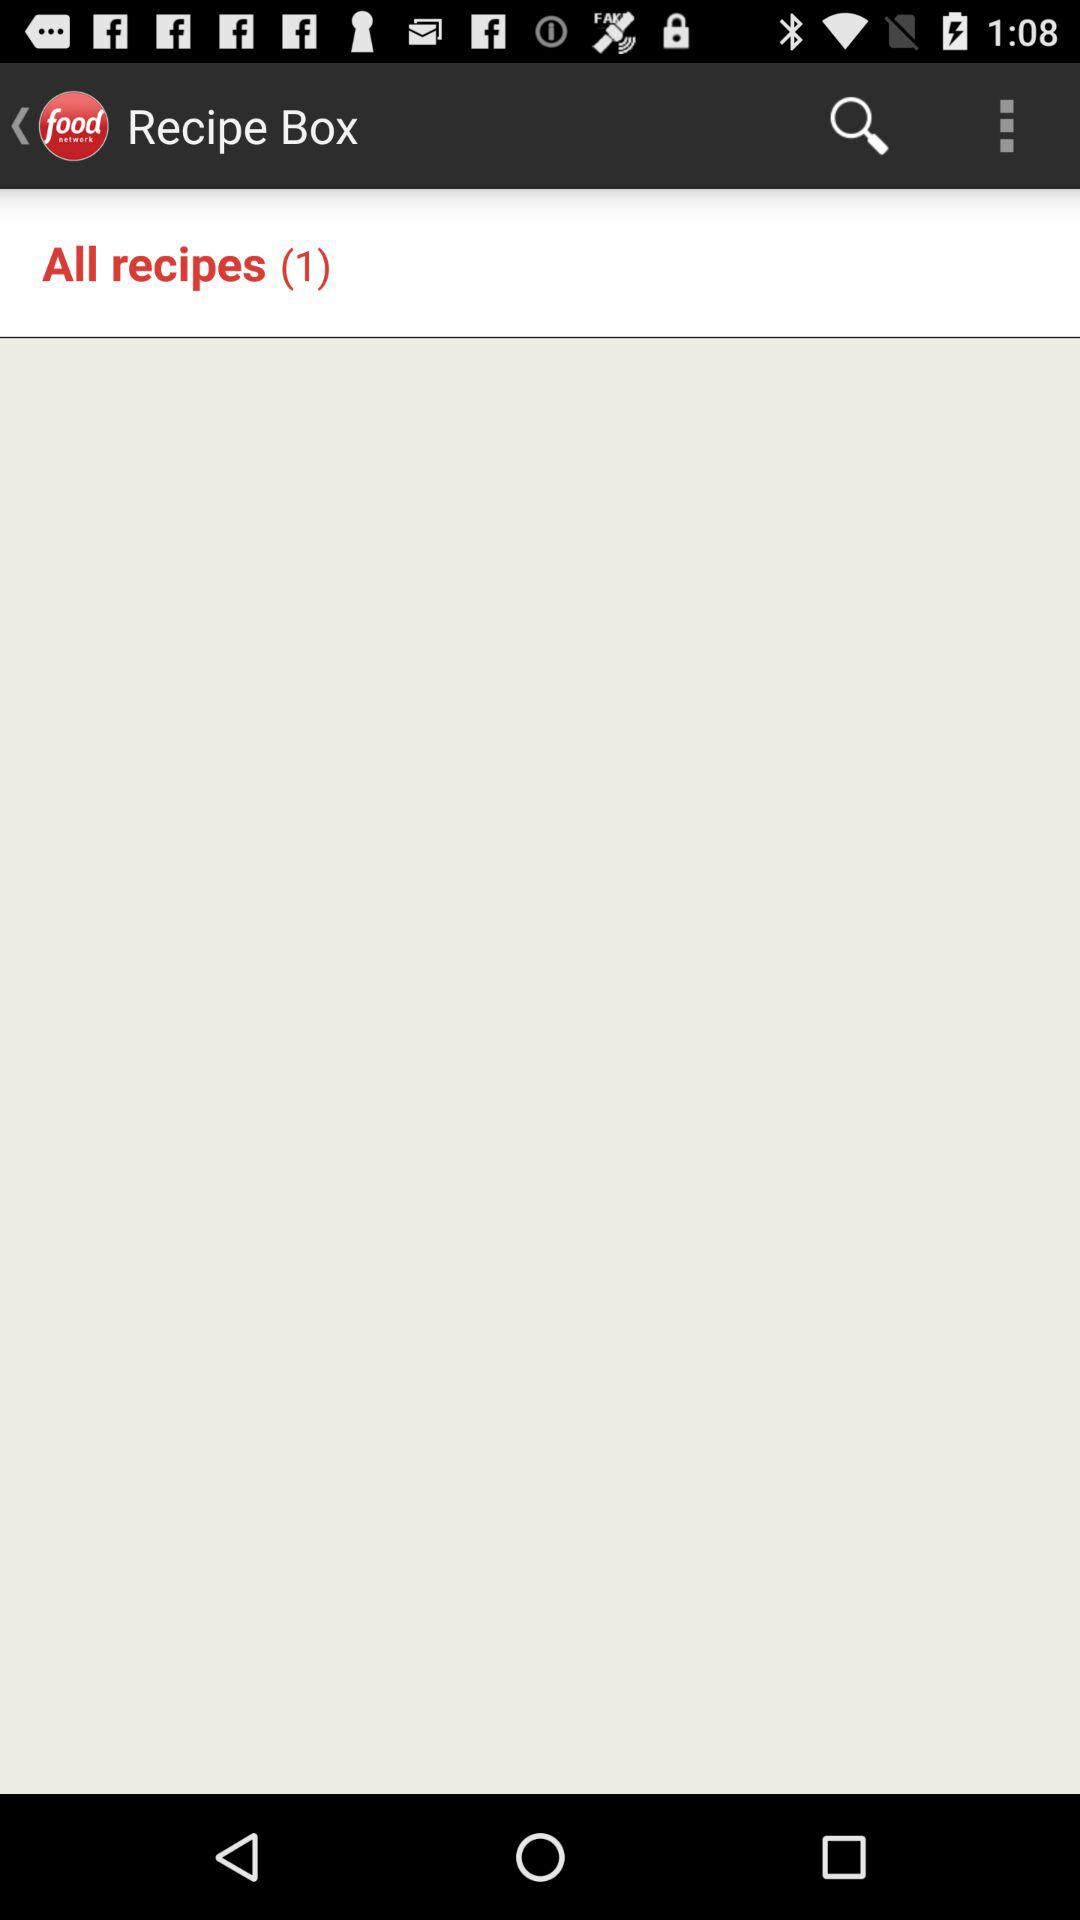How many recipes are in the recipe box? There is 1 recipe in the recipie box. 